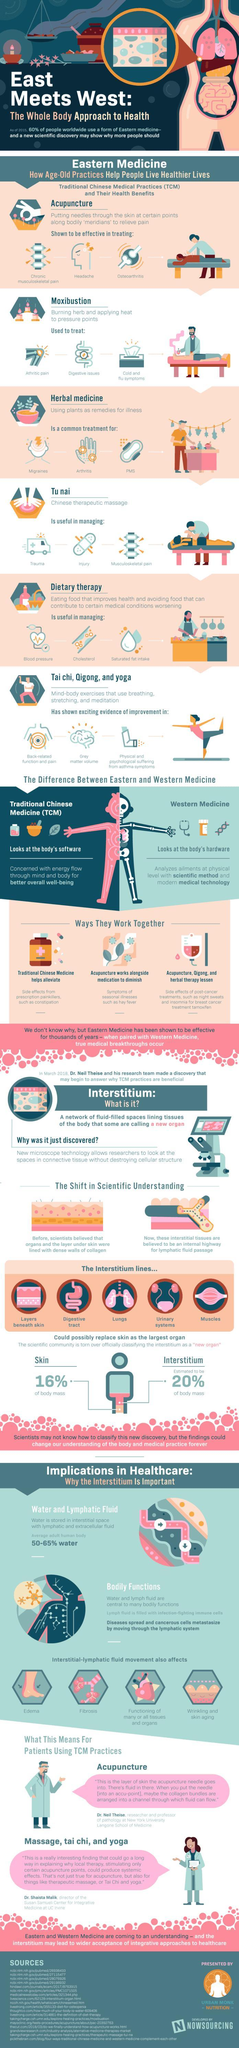Which system of medicine analyzes ailments at physical level with modern technology?
Answer the question with a short phrase. Western medicine Which methods can together help in reducing side effects of post-cancer treatments like night sweats and insomnia? Acupuncture, Qigong, and herbal therapy Which method of treatment can help alleviate symptoms of illnesses like hay fever? Acupuncture Which system of medicine looks at the body's software? Traditional Chinese Medicine Which method of treatment is used in treatment of cold and flu symptoms? Moxibustion Which system of medicine is concerned with overall well-being of mind and body? Traditional Chinese Medicine 